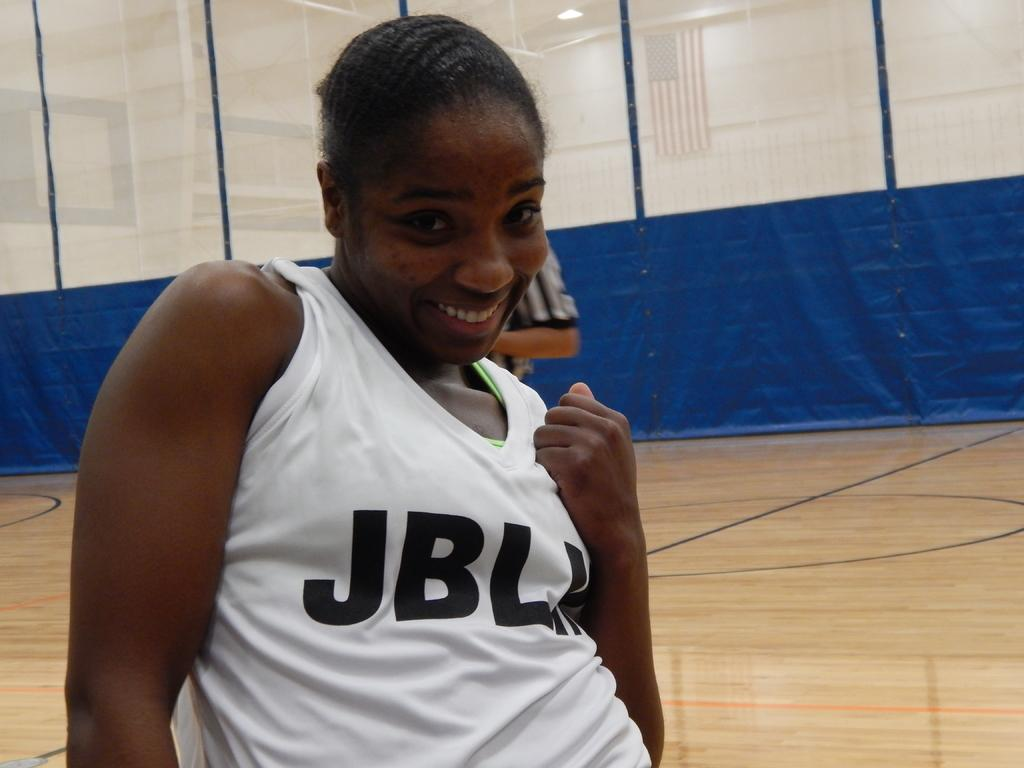<image>
Share a concise interpretation of the image provided. A young black woman wearing a white tank with the letters JBL and one more I can't make out on it. 